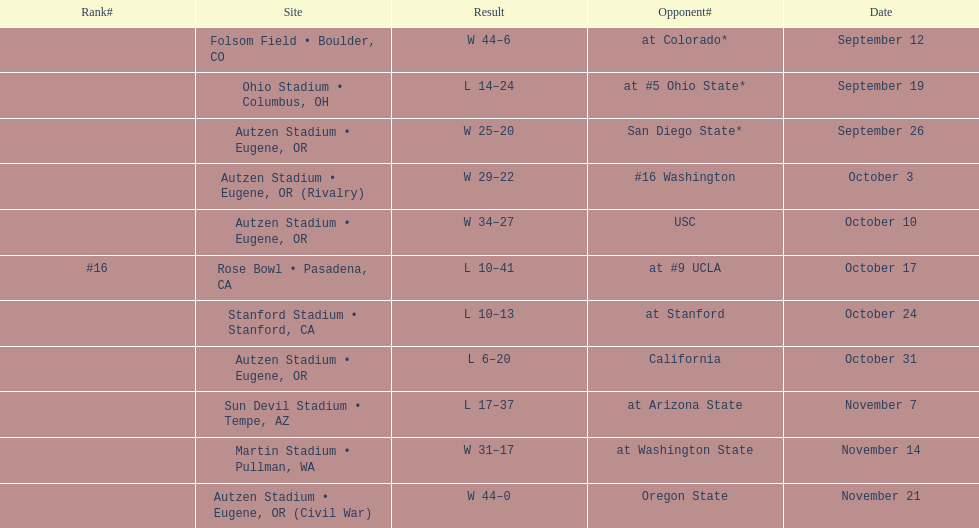How many successful matches are noted for the season? 6. 